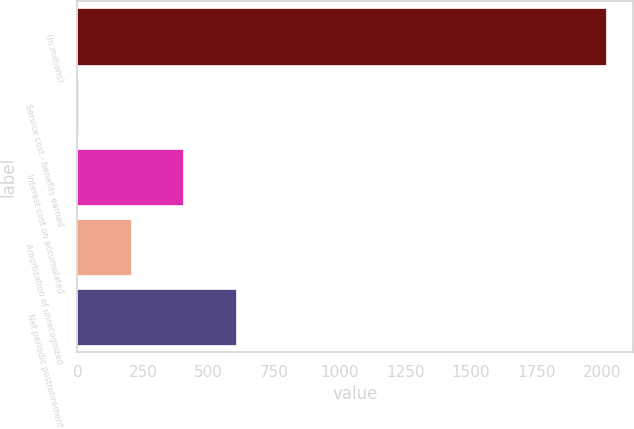Convert chart. <chart><loc_0><loc_0><loc_500><loc_500><bar_chart><fcel>(In millions)<fcel>Service cost - benefits earned<fcel>Interest cost on accumulated<fcel>Amortization of unrecognized<fcel>Net periodic postretirement<nl><fcel>2017<fcel>1<fcel>404.2<fcel>202.6<fcel>605.8<nl></chart> 